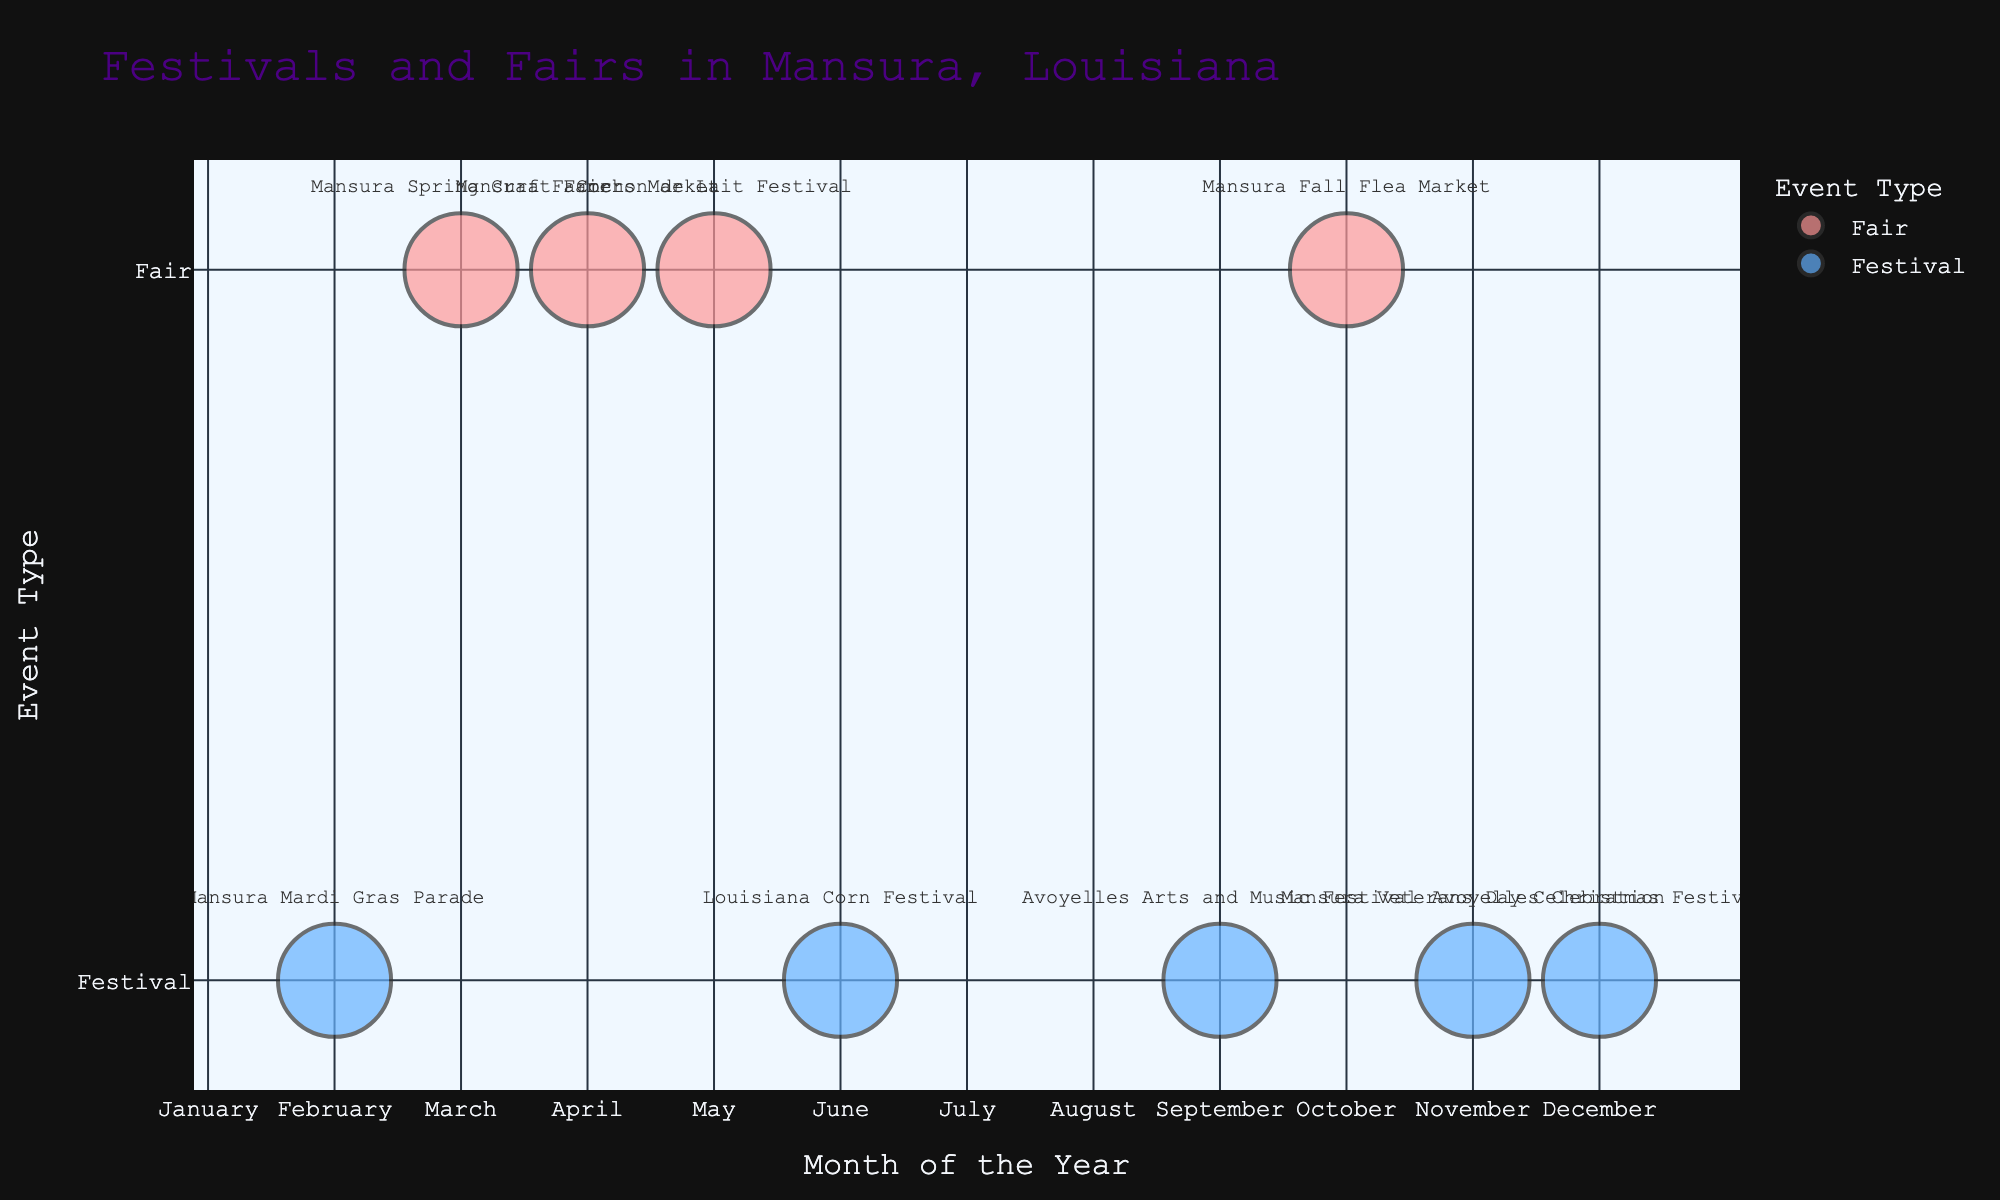How many festivals are there in December? Look at the 'Month' and 'Frequency' columns and find the data point corresponding to December. The chart shows "Avoyelles Christmas Festival" in December with a frequency of 1.
Answer: 1 Which month has the highest number of fairs? Compare the frequency of fairs in each month. The chart shows fairs in March, April, May, and October, each with a frequency of 1. Thus, no month has multiple fairs.
Answer: No month has multiple fairs Is there any event in July? Refer to the bubble chart and check for any data points plotted for the month of July. The chart shows no bubbles for July.
Answer: No What is the total number of festivals throughout the year? Add up the frequencies of all the festival events. The chart shows festivals in February, June, September, November, and December, each with a frequency of 1. Total sum is 1+1+1+1+1.
Answer: 5 How does the number of fairs compare to the number of festivals? Count the number of fairs and festivals based on color representation. The chart shows 4 fairs and 5 festivals.
Answer: There are 4 fairs and 5 festivals Which type of events takes place in May and December respectively? Identify the bubbles for May and December, and note down their event types. The chart shows a fair in May and a festival in December.
Answer: Fair in May, Festival in December Which months have both fairs and festivals? Look for months that have multiple colored bubbles. The chart does not show any month with both fairs and festivals.
Answer: No month has both How many events occur in the spring months (March, April, May)? Sum the frequencies of events in March, April, and May. The chart shows 1 event each in March, April, and May, so 1+1+1.
Answer: 3 Do any two months have the same number of events? Compare the frequency of events for each month. The chart shows that all months with events each have a frequency of 1, indicating equal number of events in those months.
Answer: Yes, all months with events have the same number 